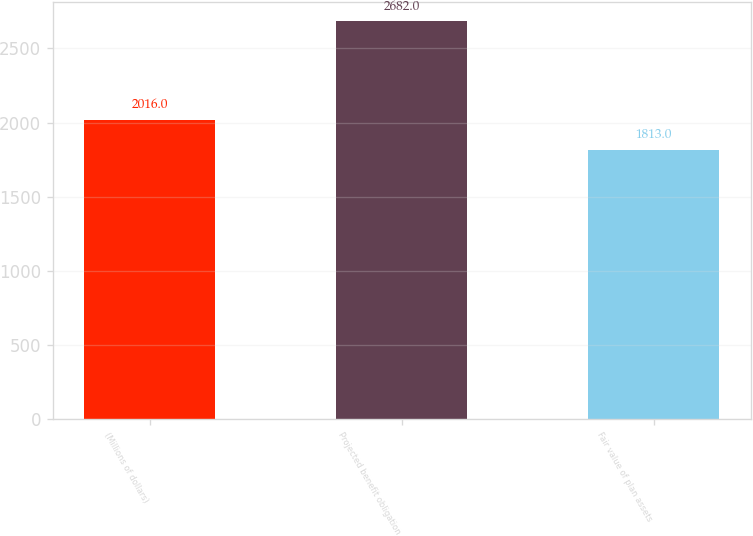<chart> <loc_0><loc_0><loc_500><loc_500><bar_chart><fcel>(Millions of dollars)<fcel>Projected benefit obligation<fcel>Fair value of plan assets<nl><fcel>2016<fcel>2682<fcel>1813<nl></chart> 